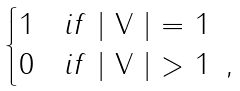<formula> <loc_0><loc_0><loc_500><loc_500>\begin{cases} 1 \quad i f $ | V | = 1 $ \\ 0 \quad i f $ | V | > 1 $ \, , \end{cases}</formula> 